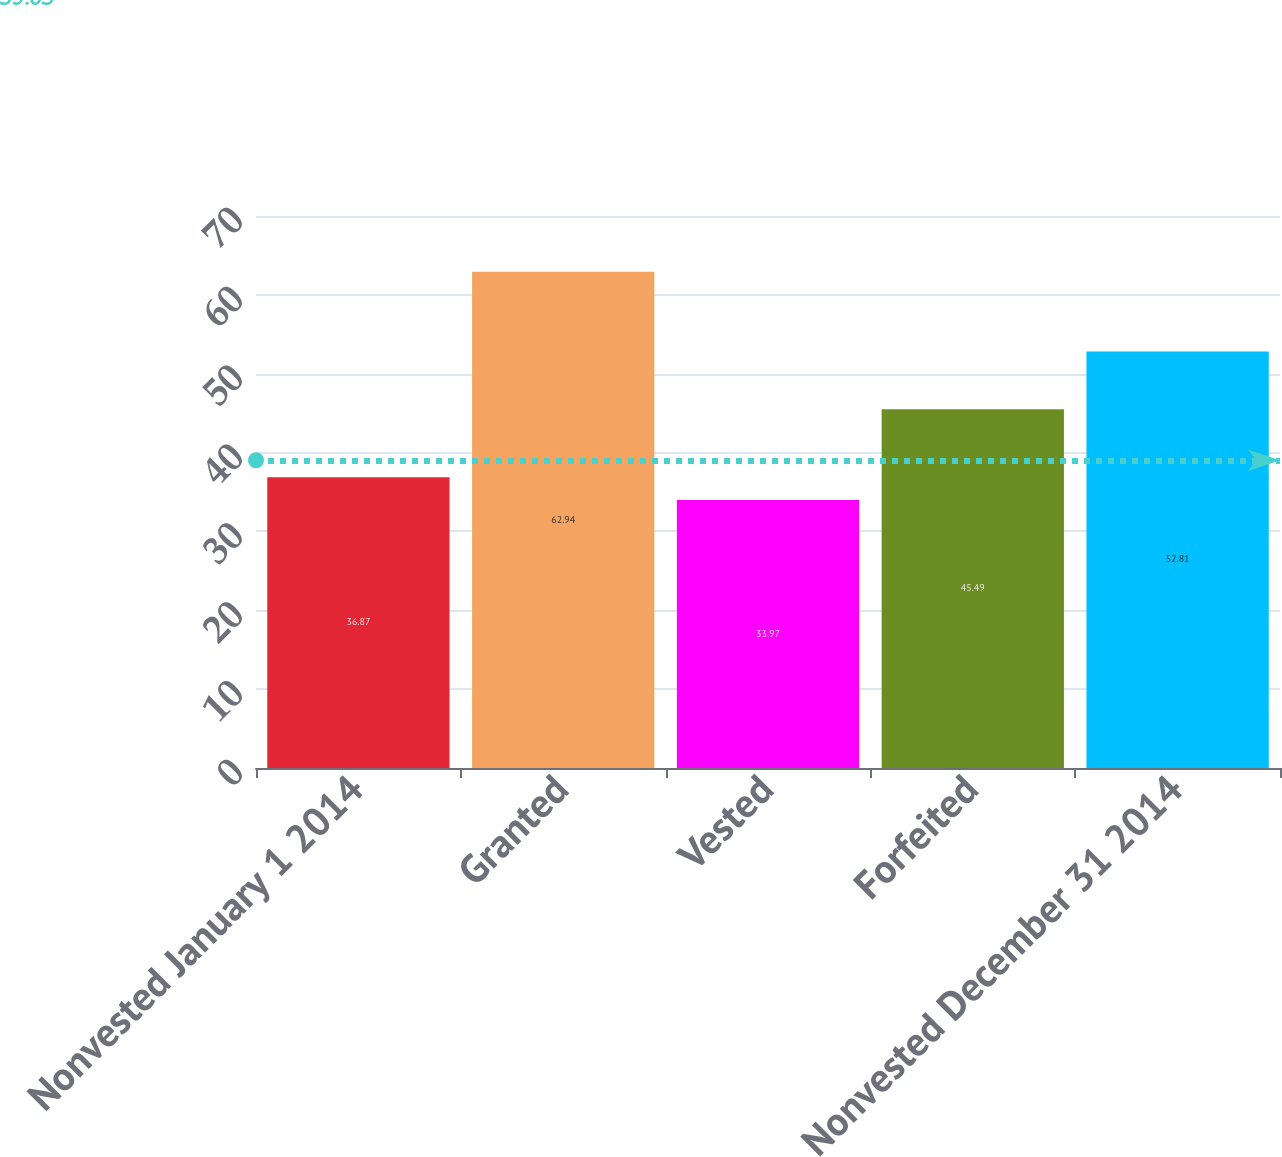Convert chart to OTSL. <chart><loc_0><loc_0><loc_500><loc_500><bar_chart><fcel>Nonvested January 1 2014<fcel>Granted<fcel>Vested<fcel>Forfeited<fcel>Nonvested December 31 2014<nl><fcel>36.87<fcel>62.94<fcel>33.97<fcel>45.49<fcel>52.81<nl></chart> 